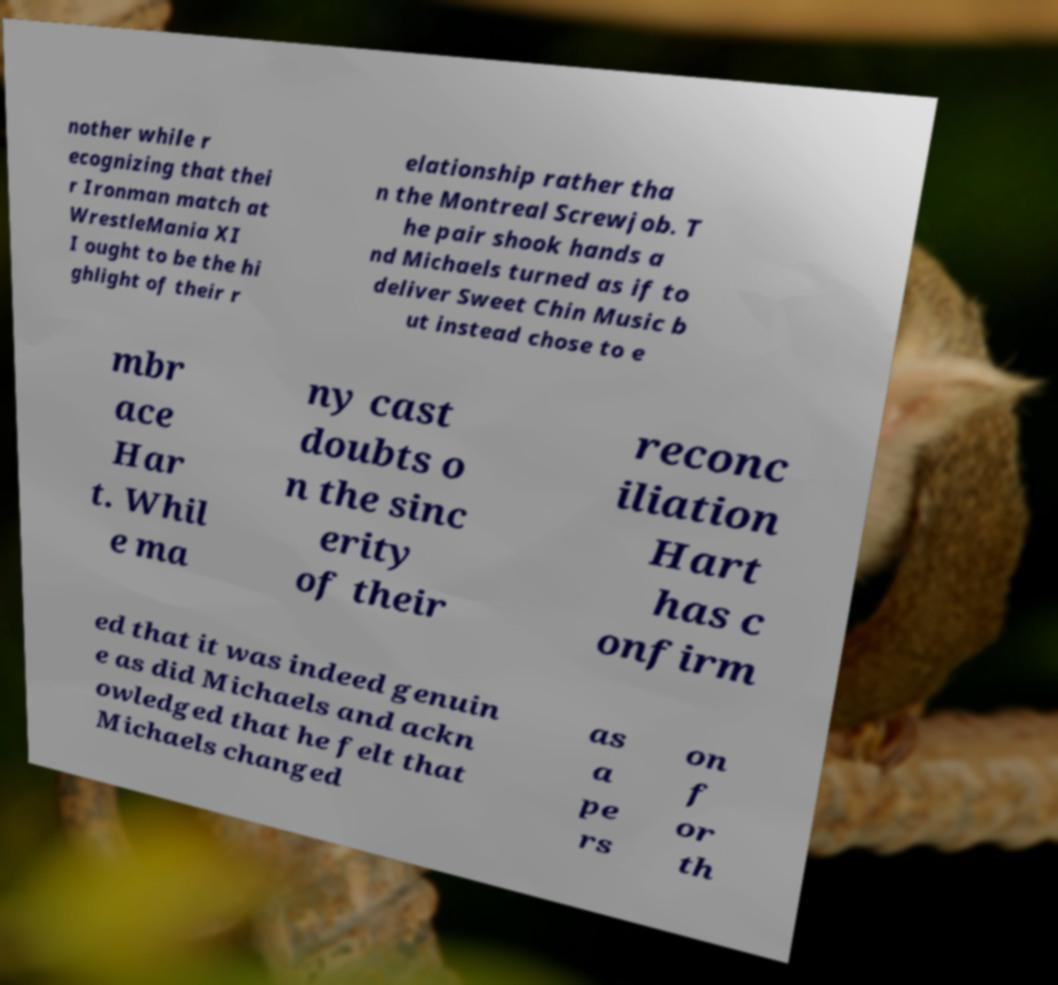What messages or text are displayed in this image? I need them in a readable, typed format. nother while r ecognizing that thei r Ironman match at WrestleMania XI I ought to be the hi ghlight of their r elationship rather tha n the Montreal Screwjob. T he pair shook hands a nd Michaels turned as if to deliver Sweet Chin Music b ut instead chose to e mbr ace Har t. Whil e ma ny cast doubts o n the sinc erity of their reconc iliation Hart has c onfirm ed that it was indeed genuin e as did Michaels and ackn owledged that he felt that Michaels changed as a pe rs on f or th 